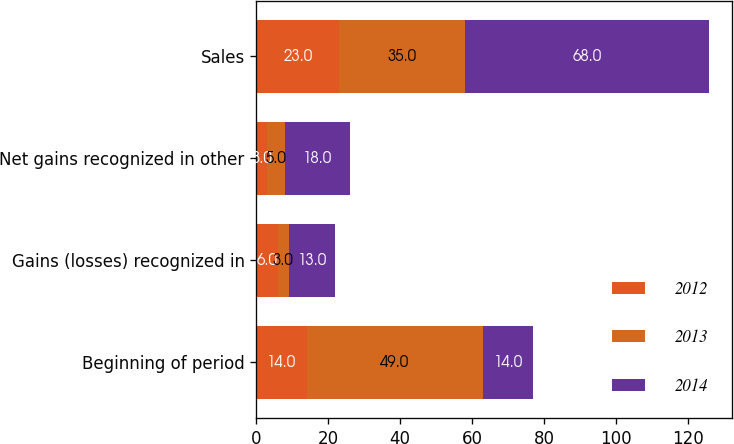<chart> <loc_0><loc_0><loc_500><loc_500><stacked_bar_chart><ecel><fcel>Beginning of period<fcel>Gains (losses) recognized in<fcel>Net gains recognized in other<fcel>Sales<nl><fcel>2012<fcel>14<fcel>6<fcel>3<fcel>23<nl><fcel>2013<fcel>49<fcel>3<fcel>5<fcel>35<nl><fcel>2014<fcel>14<fcel>13<fcel>18<fcel>68<nl></chart> 